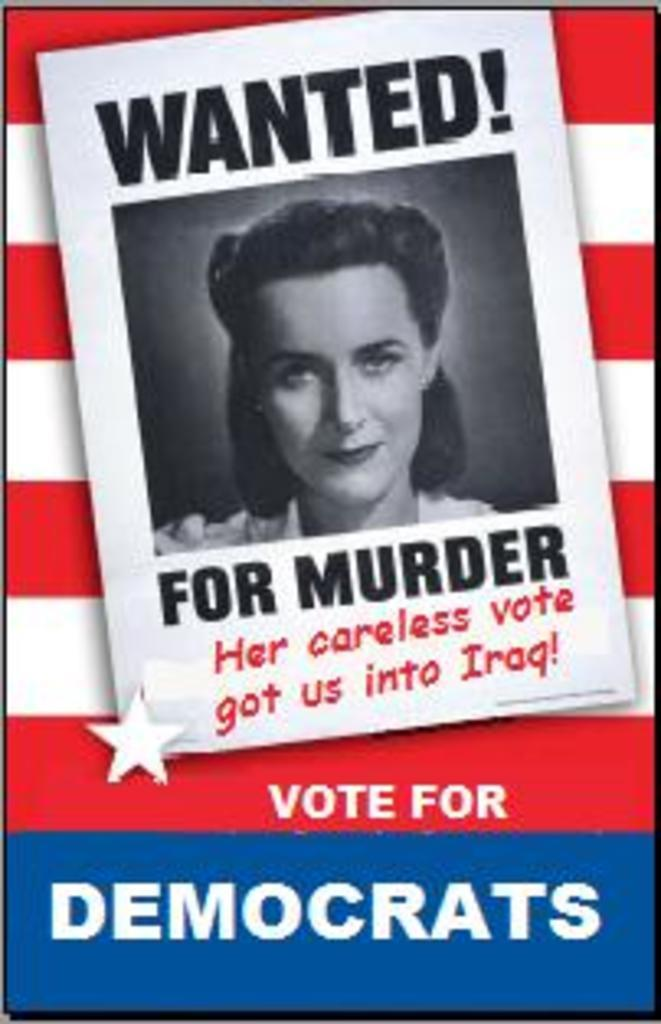What is the main subject of the image? The main subject of the image is a photograph of a woman. What is written at the top of the image? The word "Wanted" is written at the top of the image. What type of ship is mentioned in the image? There is no mention of a ship in the image. What is the woman's interest in the image? The image does not provide information about the woman's interests. 